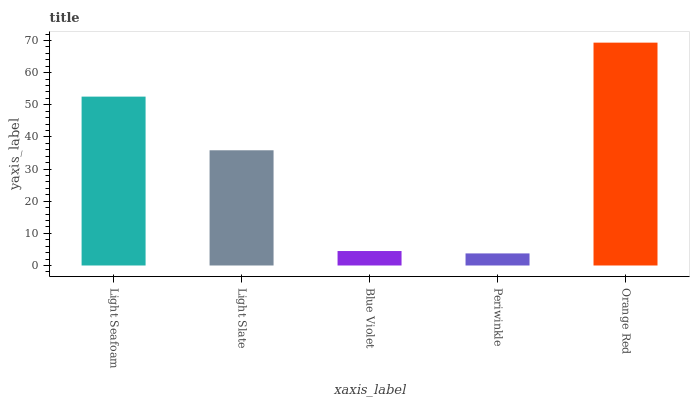Is Periwinkle the minimum?
Answer yes or no. Yes. Is Orange Red the maximum?
Answer yes or no. Yes. Is Light Slate the minimum?
Answer yes or no. No. Is Light Slate the maximum?
Answer yes or no. No. Is Light Seafoam greater than Light Slate?
Answer yes or no. Yes. Is Light Slate less than Light Seafoam?
Answer yes or no. Yes. Is Light Slate greater than Light Seafoam?
Answer yes or no. No. Is Light Seafoam less than Light Slate?
Answer yes or no. No. Is Light Slate the high median?
Answer yes or no. Yes. Is Light Slate the low median?
Answer yes or no. Yes. Is Periwinkle the high median?
Answer yes or no. No. Is Light Seafoam the low median?
Answer yes or no. No. 